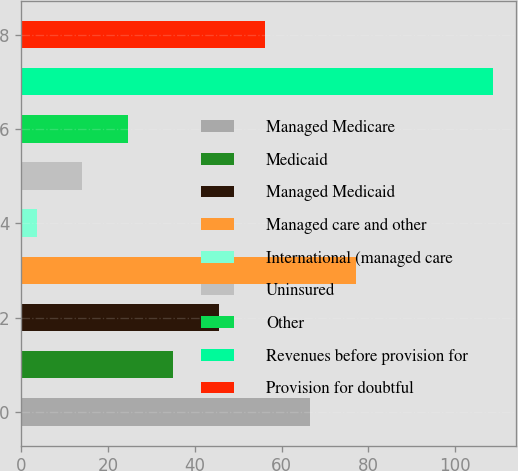<chart> <loc_0><loc_0><loc_500><loc_500><bar_chart><fcel>Managed Medicare<fcel>Medicaid<fcel>Managed Medicaid<fcel>Managed care and other<fcel>International (managed care<fcel>Uninsured<fcel>Other<fcel>Revenues before provision for<fcel>Provision for doubtful<nl><fcel>66.6<fcel>35.1<fcel>45.6<fcel>77.1<fcel>3.6<fcel>14.1<fcel>24.6<fcel>108.6<fcel>56.1<nl></chart> 